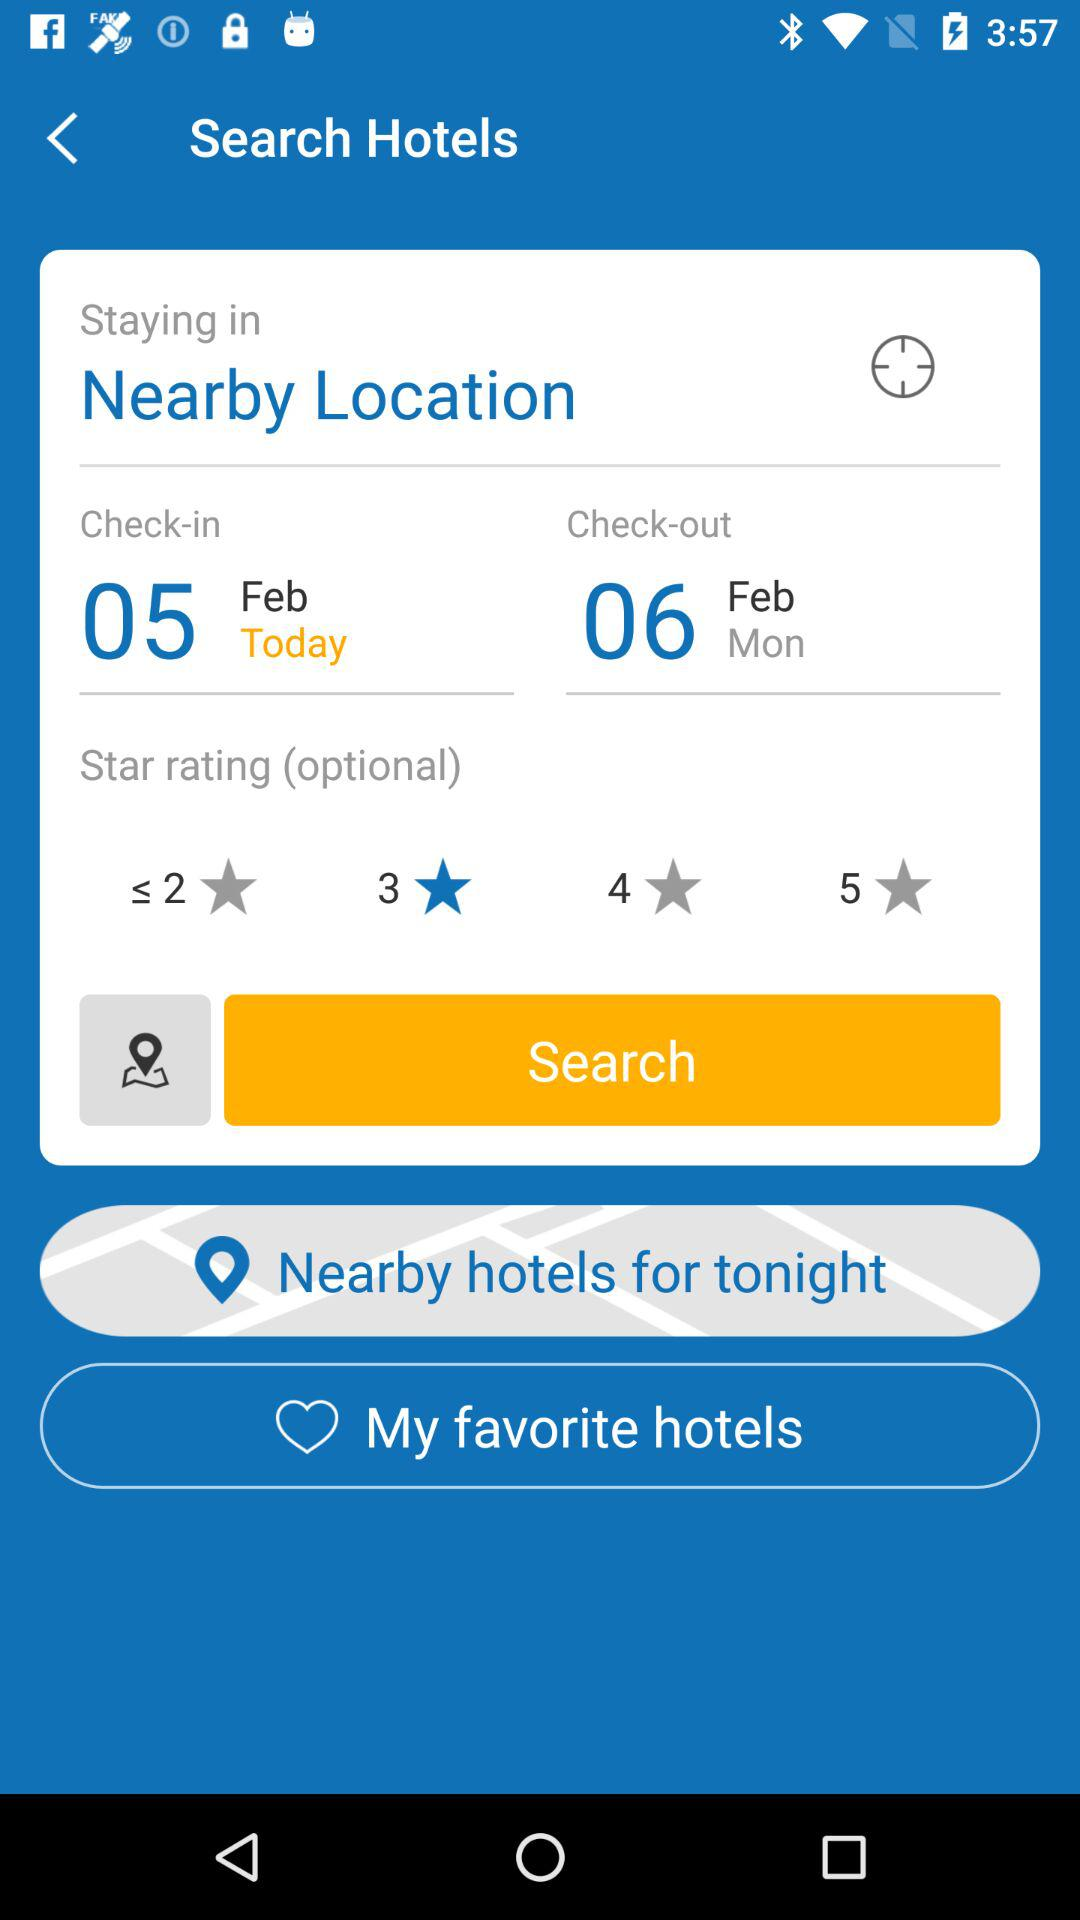Which day is the check-out? The day is Monday. 